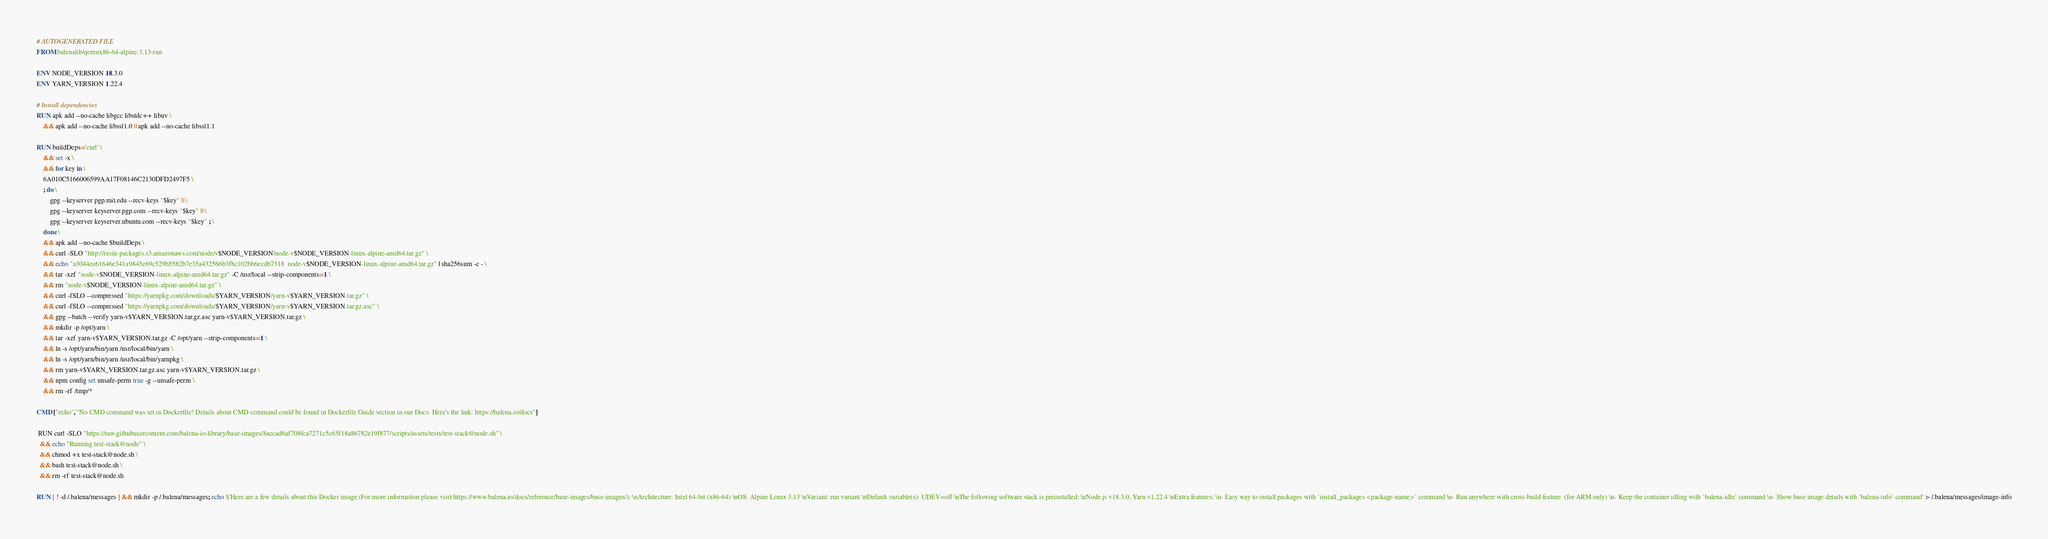<code> <loc_0><loc_0><loc_500><loc_500><_Dockerfile_># AUTOGENERATED FILE
FROM balenalib/qemux86-64-alpine:3.13-run

ENV NODE_VERSION 18.3.0
ENV YARN_VERSION 1.22.4

# Install dependencies
RUN apk add --no-cache libgcc libstdc++ libuv \
	&& apk add --no-cache libssl1.0 || apk add --no-cache libssl1.1

RUN buildDeps='curl' \
	&& set -x \
	&& for key in \
	6A010C5166006599AA17F08146C2130DFD2497F5 \
	; do \
		gpg --keyserver pgp.mit.edu --recv-keys "$key" || \
		gpg --keyserver keyserver.pgp.com --recv-keys "$key" || \
		gpg --keyserver keyserver.ubuntu.com --recv-keys "$key" ; \
	done \
	&& apk add --no-cache $buildDeps \
	&& curl -SLO "http://resin-packages.s3.amazonaws.com/node/v$NODE_VERSION/node-v$NODE_VERSION-linux-alpine-amd64.tar.gz" \
	&& echo "a3044ec61646e341a9845c69c529b5582b7e35a432566b3f8c102bb6ecd67318  node-v$NODE_VERSION-linux-alpine-amd64.tar.gz" | sha256sum -c - \
	&& tar -xzf "node-v$NODE_VERSION-linux-alpine-amd64.tar.gz" -C /usr/local --strip-components=1 \
	&& rm "node-v$NODE_VERSION-linux-alpine-amd64.tar.gz" \
	&& curl -fSLO --compressed "https://yarnpkg.com/downloads/$YARN_VERSION/yarn-v$YARN_VERSION.tar.gz" \
	&& curl -fSLO --compressed "https://yarnpkg.com/downloads/$YARN_VERSION/yarn-v$YARN_VERSION.tar.gz.asc" \
	&& gpg --batch --verify yarn-v$YARN_VERSION.tar.gz.asc yarn-v$YARN_VERSION.tar.gz \
	&& mkdir -p /opt/yarn \
	&& tar -xzf yarn-v$YARN_VERSION.tar.gz -C /opt/yarn --strip-components=1 \
	&& ln -s /opt/yarn/bin/yarn /usr/local/bin/yarn \
	&& ln -s /opt/yarn/bin/yarn /usr/local/bin/yarnpkg \
	&& rm yarn-v$YARN_VERSION.tar.gz.asc yarn-v$YARN_VERSION.tar.gz \
	&& npm config set unsafe-perm true -g --unsafe-perm \
	&& rm -rf /tmp/*

CMD ["echo","'No CMD command was set in Dockerfile! Details about CMD command could be found in Dockerfile Guide section in our Docs. Here's the link: https://balena.io/docs"]

 RUN curl -SLO "https://raw.githubusercontent.com/balena-io-library/base-images/8accad6af708fca7271c5c65f18a86782e19f877/scripts/assets/tests/test-stack@node.sh" \
  && echo "Running test-stack@node" \
  && chmod +x test-stack@node.sh \
  && bash test-stack@node.sh \
  && rm -rf test-stack@node.sh 

RUN [ ! -d /.balena/messages ] && mkdir -p /.balena/messages; echo $'Here are a few details about this Docker image (For more information please visit https://www.balena.io/docs/reference/base-images/base-images/): \nArchitecture: Intel 64-bit (x86-64) \nOS: Alpine Linux 3.13 \nVariant: run variant \nDefault variable(s): UDEV=off \nThe following software stack is preinstalled: \nNode.js v18.3.0, Yarn v1.22.4 \nExtra features: \n- Easy way to install packages with `install_packages <package-name>` command \n- Run anywhere with cross-build feature  (for ARM only) \n- Keep the container idling with `balena-idle` command \n- Show base image details with `balena-info` command' > /.balena/messages/image-info</code> 